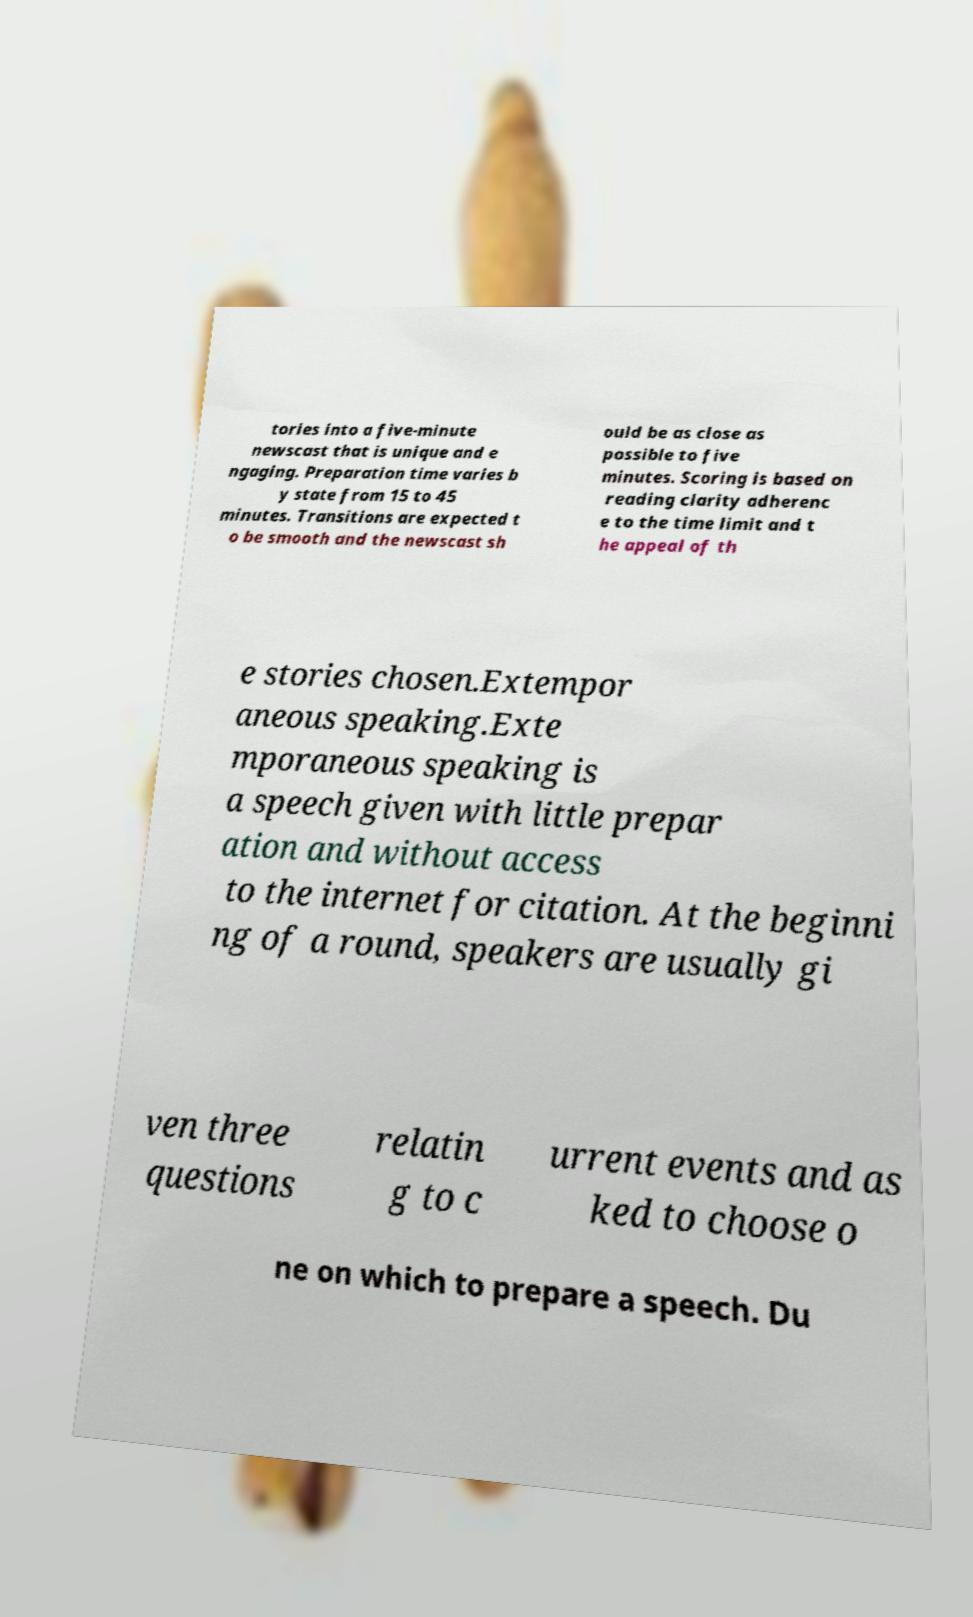Could you assist in decoding the text presented in this image and type it out clearly? tories into a five-minute newscast that is unique and e ngaging. Preparation time varies b y state from 15 to 45 minutes. Transitions are expected t o be smooth and the newscast sh ould be as close as possible to five minutes. Scoring is based on reading clarity adherenc e to the time limit and t he appeal of th e stories chosen.Extempor aneous speaking.Exte mporaneous speaking is a speech given with little prepar ation and without access to the internet for citation. At the beginni ng of a round, speakers are usually gi ven three questions relatin g to c urrent events and as ked to choose o ne on which to prepare a speech. Du 